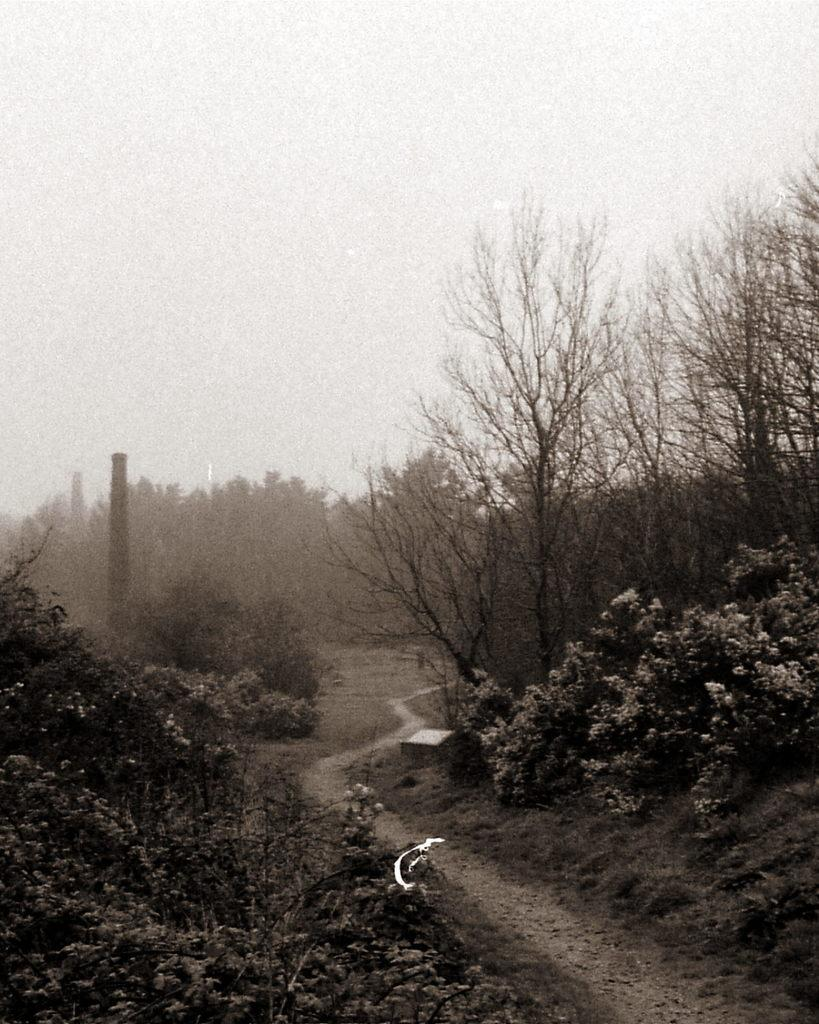What type of vegetation can be seen in the image? There are trees and flowers in the image. What is visible at the top of the image? The sky is visible at the top of the image. What type of ground surface is present in the image? There is grass at the bottom of the image and a pavement in the image. What object can be seen in the image? There is an object in the image. How many babies are crawling on the pavement in the image? There are no babies present in the image; it only features trees, flowers, the sky, grass, a pavement, and an unspecified object. 